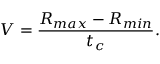<formula> <loc_0><loc_0><loc_500><loc_500>V = { \frac { R _ { \max } - R _ { \min } } { t _ { c } } } .</formula> 